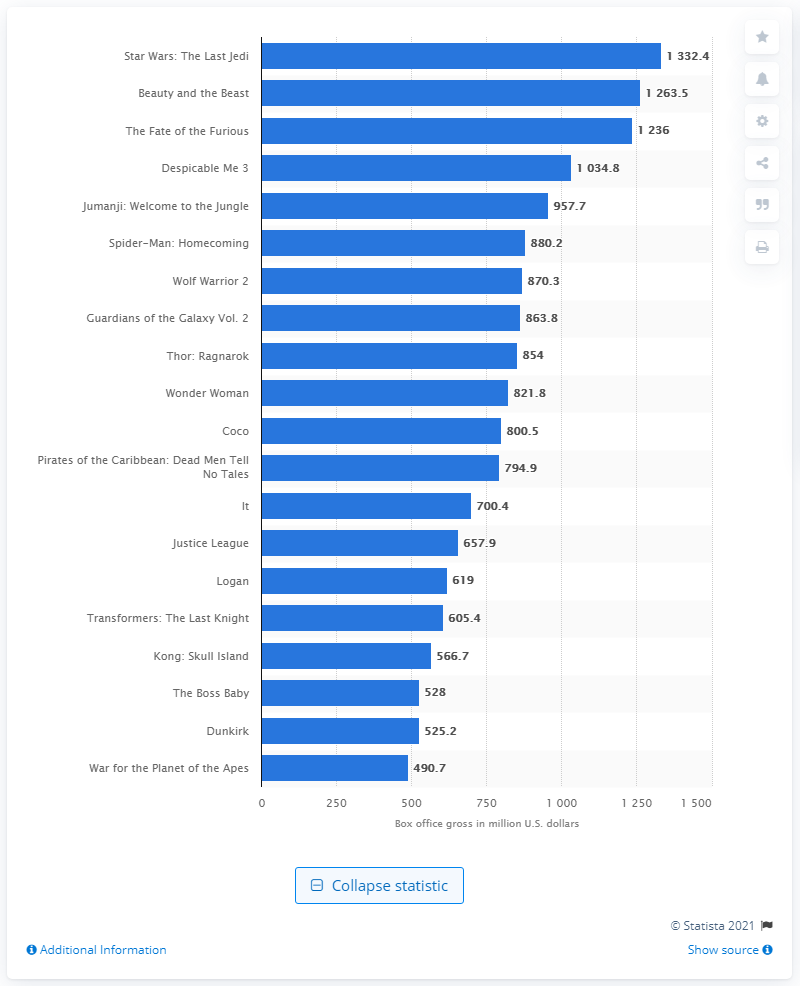Specify some key components in this picture. The movie that generated the most revenue in 2017 was Star Wars: The Last Jedi. The global box office revenue for Star Wars: The Last Jedi was 1332.4 million US dollars. 